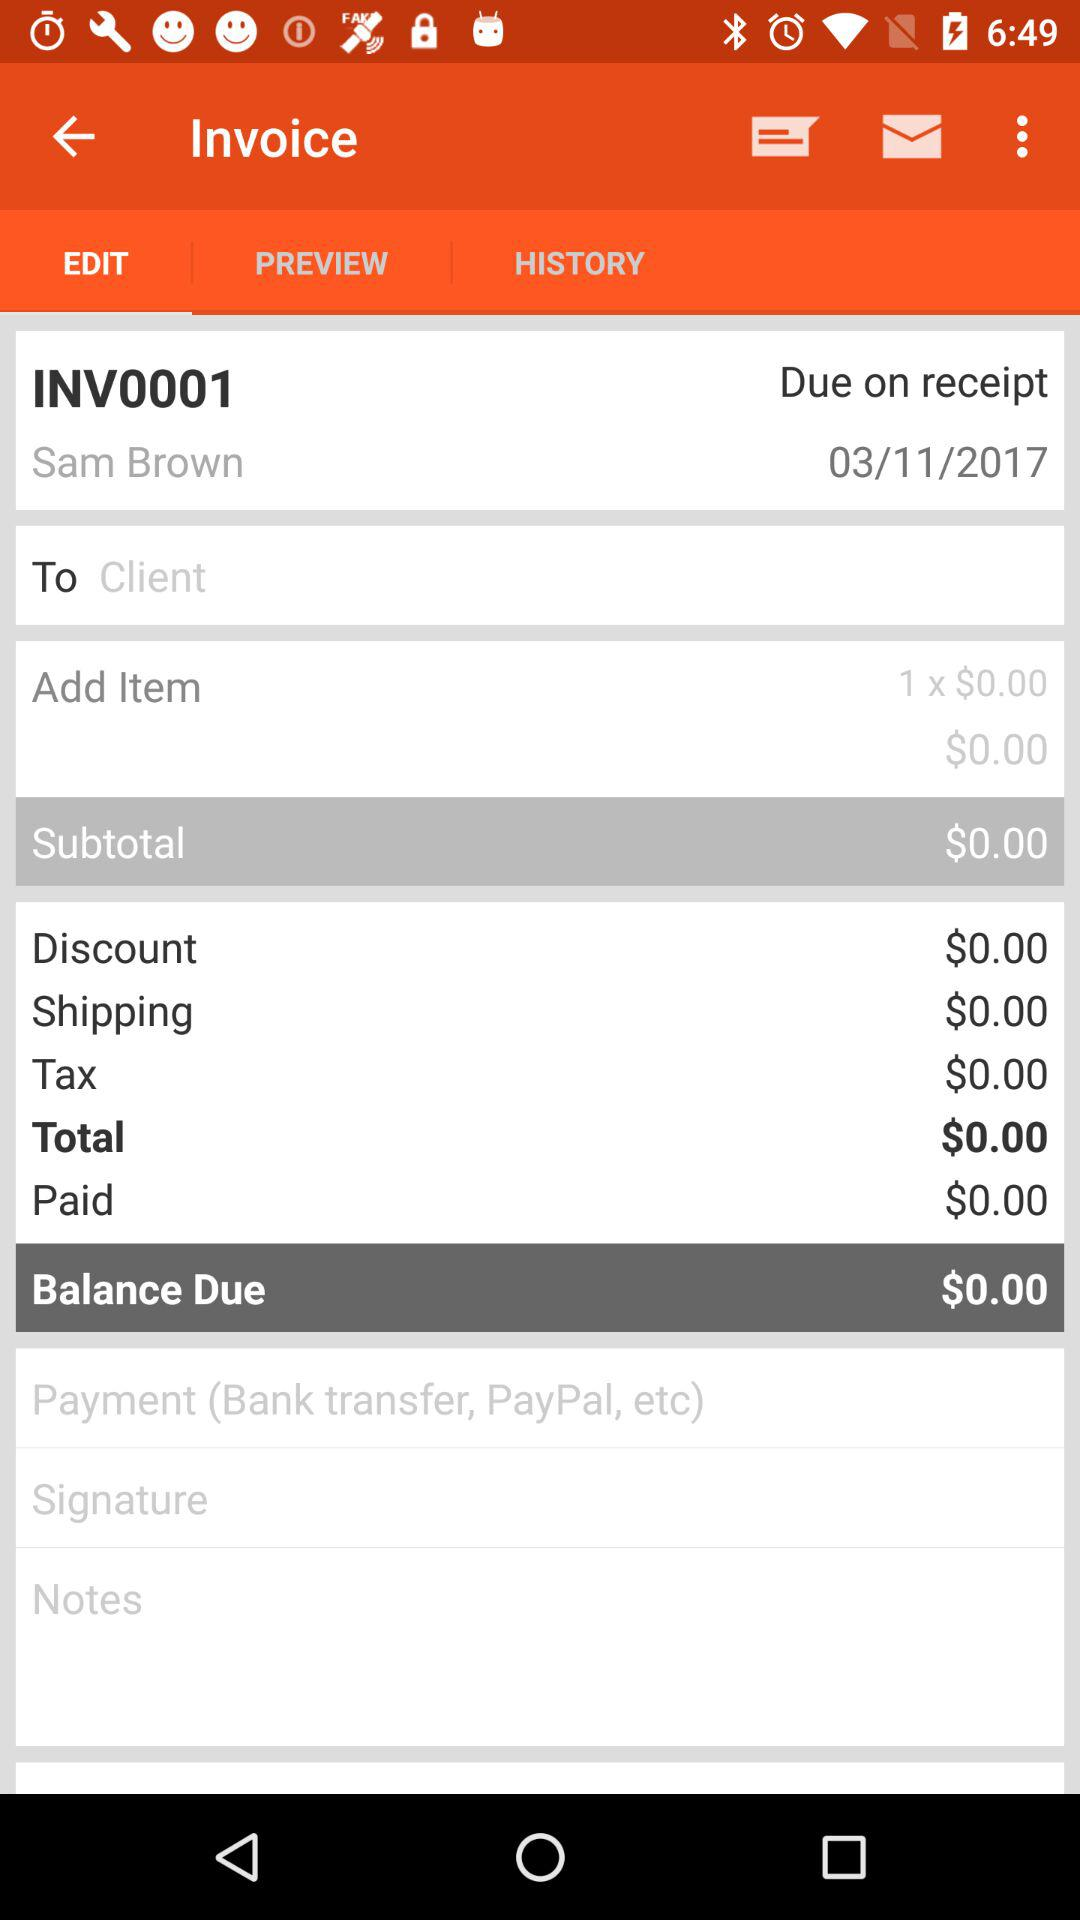What is the due date? The date is March 11, 2017. 